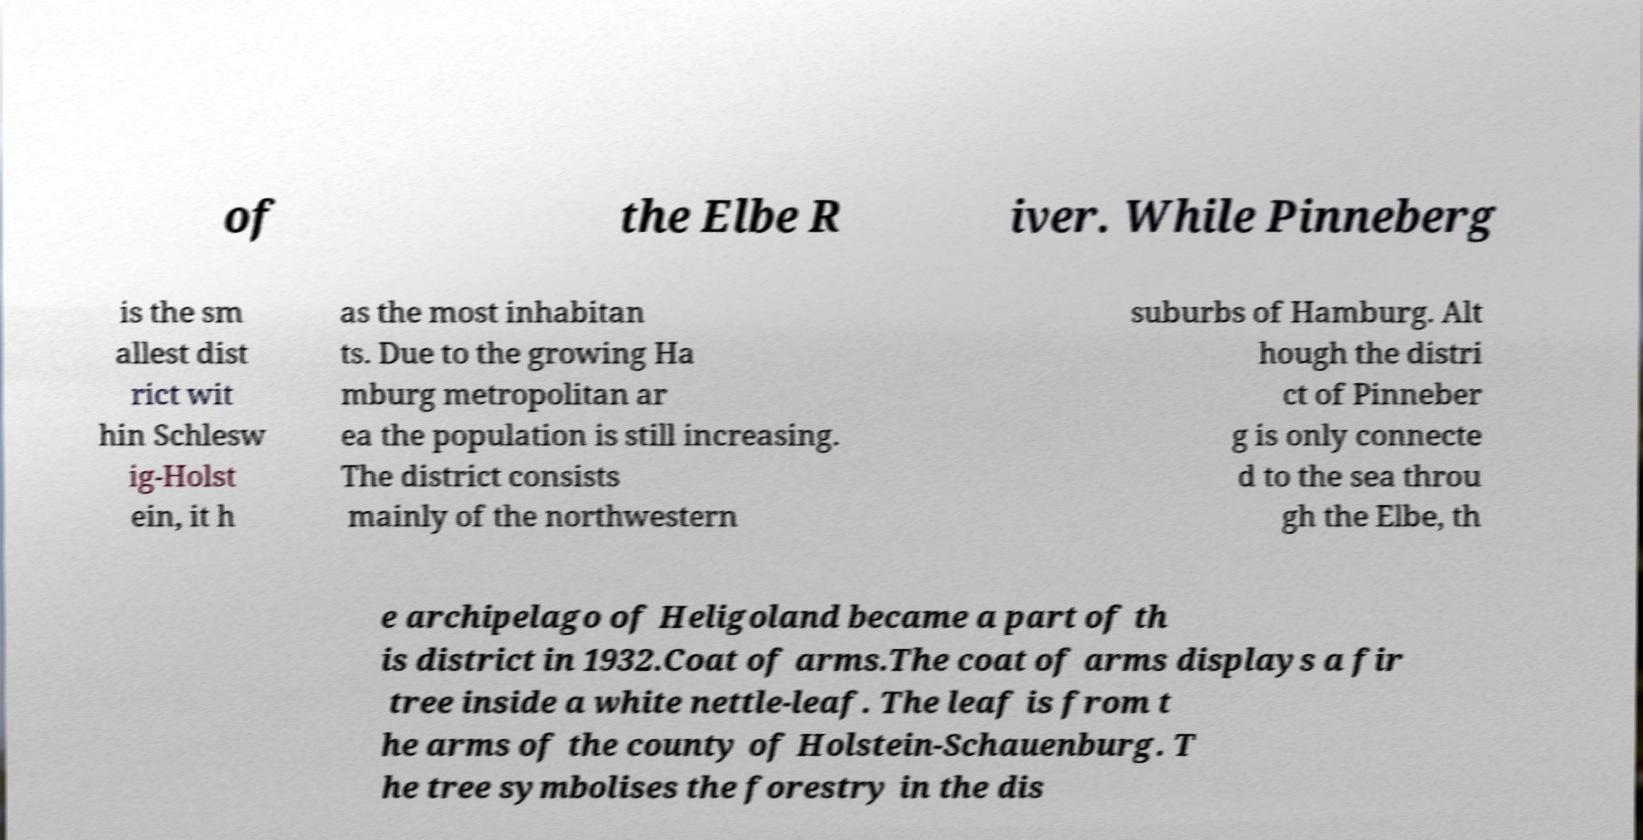What messages or text are displayed in this image? I need them in a readable, typed format. of the Elbe R iver. While Pinneberg is the sm allest dist rict wit hin Schlesw ig-Holst ein, it h as the most inhabitan ts. Due to the growing Ha mburg metropolitan ar ea the population is still increasing. The district consists mainly of the northwestern suburbs of Hamburg. Alt hough the distri ct of Pinneber g is only connecte d to the sea throu gh the Elbe, th e archipelago of Heligoland became a part of th is district in 1932.Coat of arms.The coat of arms displays a fir tree inside a white nettle-leaf. The leaf is from t he arms of the county of Holstein-Schauenburg. T he tree symbolises the forestry in the dis 